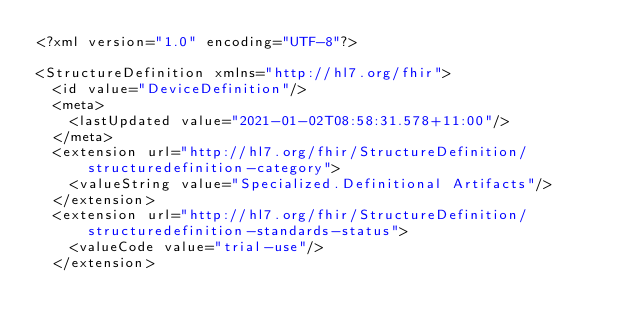Convert code to text. <code><loc_0><loc_0><loc_500><loc_500><_XML_><?xml version="1.0" encoding="UTF-8"?>

<StructureDefinition xmlns="http://hl7.org/fhir">
  <id value="DeviceDefinition"/>
  <meta>
    <lastUpdated value="2021-01-02T08:58:31.578+11:00"/>
  </meta>
  <extension url="http://hl7.org/fhir/StructureDefinition/structuredefinition-category">
    <valueString value="Specialized.Definitional Artifacts"/>
  </extension>
  <extension url="http://hl7.org/fhir/StructureDefinition/structuredefinition-standards-status">
    <valueCode value="trial-use"/>
  </extension></code> 